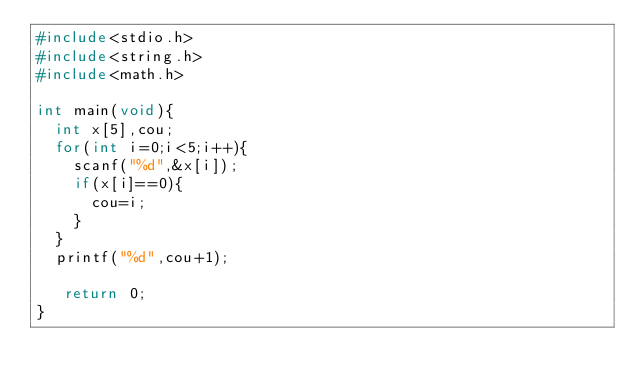Convert code to text. <code><loc_0><loc_0><loc_500><loc_500><_C_>#include<stdio.h>
#include<string.h>
#include<math.h>

int main(void){
  int x[5],cou;
  for(int i=0;i<5;i++){
    scanf("%d",&x[i]);
    if(x[i]==0){
      cou=i;
    }
  }
  printf("%d",cou+1);

   return 0;
}
</code> 